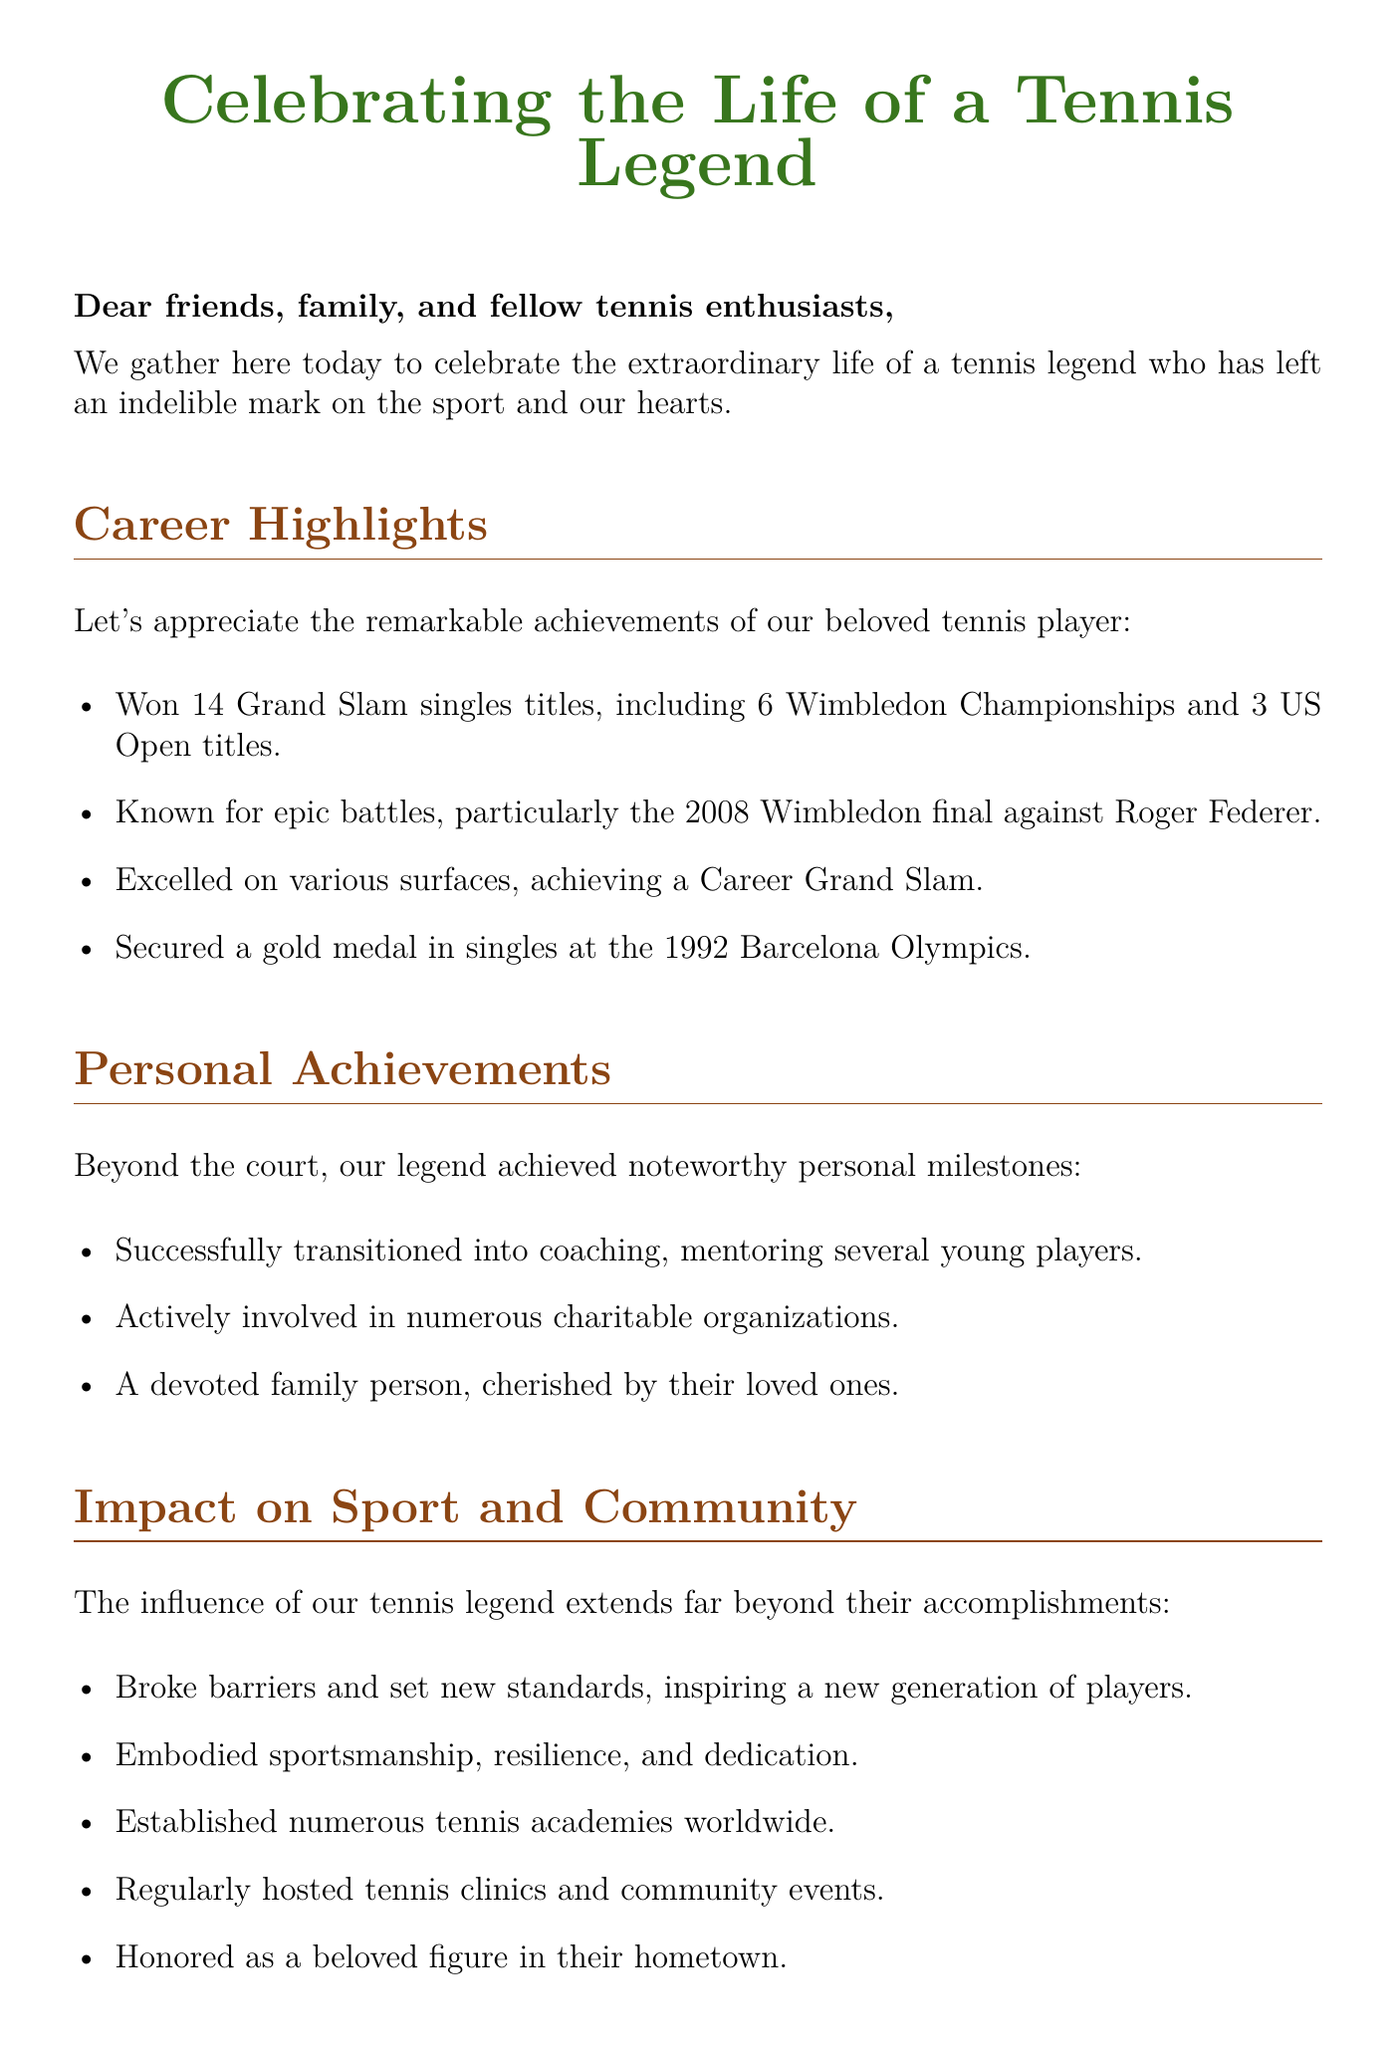what is the total number of Grand Slam singles titles won? The document states that the tennis legend won a total of 14 Grand Slam singles titles.
Answer: 14 which Olympic medal did the tennis legend secure? The document mentions that the player secured a gold medal in singles at the 1992 Barcelona Olympics.
Answer: Gold medal how many Wimbledon Championships are mentioned? According to the document, the tennis player won 6 Wimbledon Championships.
Answer: 6 what year did the remarkable 2008 Wimbledon final occur? The document specifies the year when the epic battle against Roger Federer took place as 2008.
Answer: 2008 name a personal achievement besides their career. The document lists transitioning into coaching as a personal achievement, alongside mentoring young players.
Answer: Coaching which type of events did the tennis legend regularly host? The document indicates that the legend regularly hosted tennis clinics and community events.
Answer: Tennis clinics how did the tennis legend impact the sport? The document states they broke barriers and set new standards for inspiring new players.
Answer: Inspired new generation who honored the tennis legend as a beloved figure? The document mentions that the tennis legend was honored in their hometown.
Answer: Hometown what is the primary purpose of this document? The document is created to celebrate and honor the life of a tennis legend.
Answer: Celebrate life 